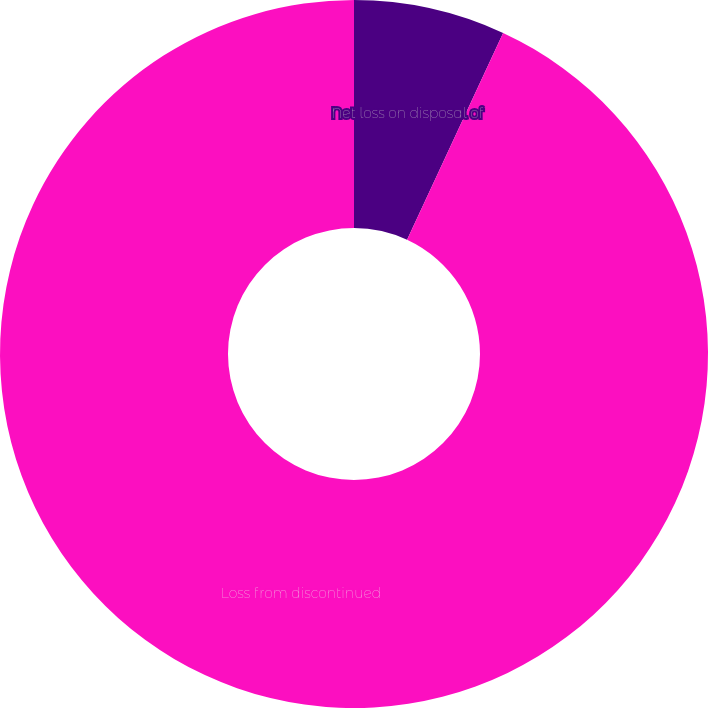Convert chart to OTSL. <chart><loc_0><loc_0><loc_500><loc_500><pie_chart><fcel>Net loss on disposal of<fcel>Loss from discontinued<nl><fcel>6.92%<fcel>93.08%<nl></chart> 